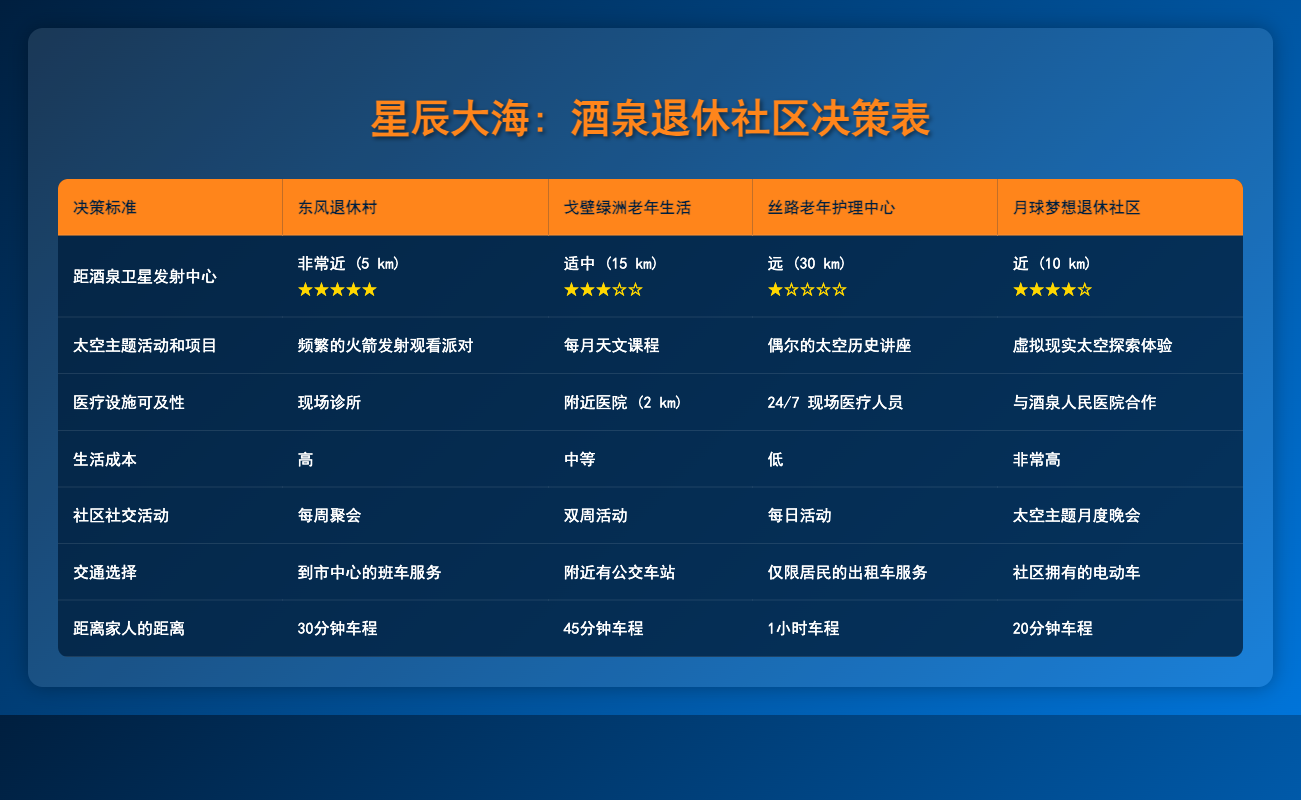What is the proximity of Dongfeng Retirement Village to the Jiuquan Satellite Launch Center? The table states that Dongfeng Retirement Village is "Very close (5 km)" to the Jiuquan Satellite Launch Center.
Answer: Very close (5 km) Which retirement community has the lowest cost of living? The table indicates that Silk Road Elderly Care Center has a "Low" cost of living, while others are noted as "High," "Moderate," or "Very high."
Answer: Silk Road Elderly Care Center How many different types of community social events are offered by Lunar Dreams Retirement Community? Lunar Dreams Retirement Community offers "Space-themed monthly galas," which counts as one type of community social event; the focus is on this specific event in the table.
Answer: 1 type Is there an on-site clinic at Dongfeng Retirement Village? According to the table, Dongfeng Retirement Village has "On-site clinic," which confirms that it does indeed have this facility.
Answer: Yes What is the average distance to family for the retirement communities listed? The distances to family are: 30 minutes (Dongfeng), 45 minutes (Gobi Oasis), 1 hour (Silk Road), and 20 minutes (Lunar Dreams). We convert to minutes: 30, 45, 60, and 20. The average is (30 + 45 + 60 + 20) / 4 = 155 / 4 = 38.75 (rounded to 39 minutes).
Answer: 39 minutes Which community offers the most frequent space-themed activities? The table states that Dongfeng Retirement Village hosts "Frequent rocket launch viewing parties," which is the most frequent when compared to the other communities listed.
Answer: Dongfeng Retirement Village In terms of transportation options, which retirement community has the most unique feature? The table lists the transportation option for Lunar Dreams Retirement Community as "Community-owned electric vehicles," which is unique compared to shuttles, public buses, and taxis offered by others.
Answer: Lunar Dreams Retirement Community Which retirement community is specifically noted for having a partnership with Jiuquan People's Hospital? The table indicates that Lunar Dreams Retirement Community has a "Partnership with Jiuquan People's Hospital," making it the only community with this specific healthcare partnership.
Answer: Lunar Dreams Retirement Community What is the difference in community social events between Dongfeng Retirement Village and Silk Road Elderly Care Center? The table shows Dongfeng has "Weekly gatherings" while Silk Road has "Daily activities." The difference is in their frequency: Daily activities happen more often than Weekly gatherings (7 days vs. 1 day).
Answer: Daily activities happen more often 